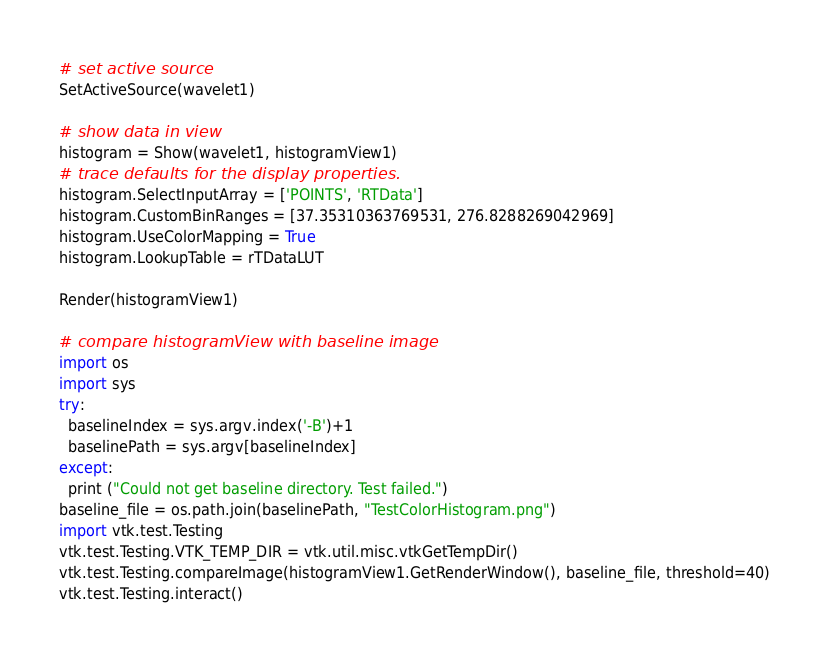Convert code to text. <code><loc_0><loc_0><loc_500><loc_500><_Python_>
# set active source
SetActiveSource(wavelet1)

# show data in view
histogram = Show(wavelet1, histogramView1)
# trace defaults for the display properties.
histogram.SelectInputArray = ['POINTS', 'RTData']
histogram.CustomBinRanges = [37.35310363769531, 276.8288269042969]
histogram.UseColorMapping = True
histogram.LookupTable = rTDataLUT

Render(histogramView1)

# compare histogramView with baseline image
import os
import sys
try:
  baselineIndex = sys.argv.index('-B')+1
  baselinePath = sys.argv[baselineIndex]
except:
  print ("Could not get baseline directory. Test failed.")
baseline_file = os.path.join(baselinePath, "TestColorHistogram.png")
import vtk.test.Testing
vtk.test.Testing.VTK_TEMP_DIR = vtk.util.misc.vtkGetTempDir()
vtk.test.Testing.compareImage(histogramView1.GetRenderWindow(), baseline_file, threshold=40)
vtk.test.Testing.interact()
</code> 